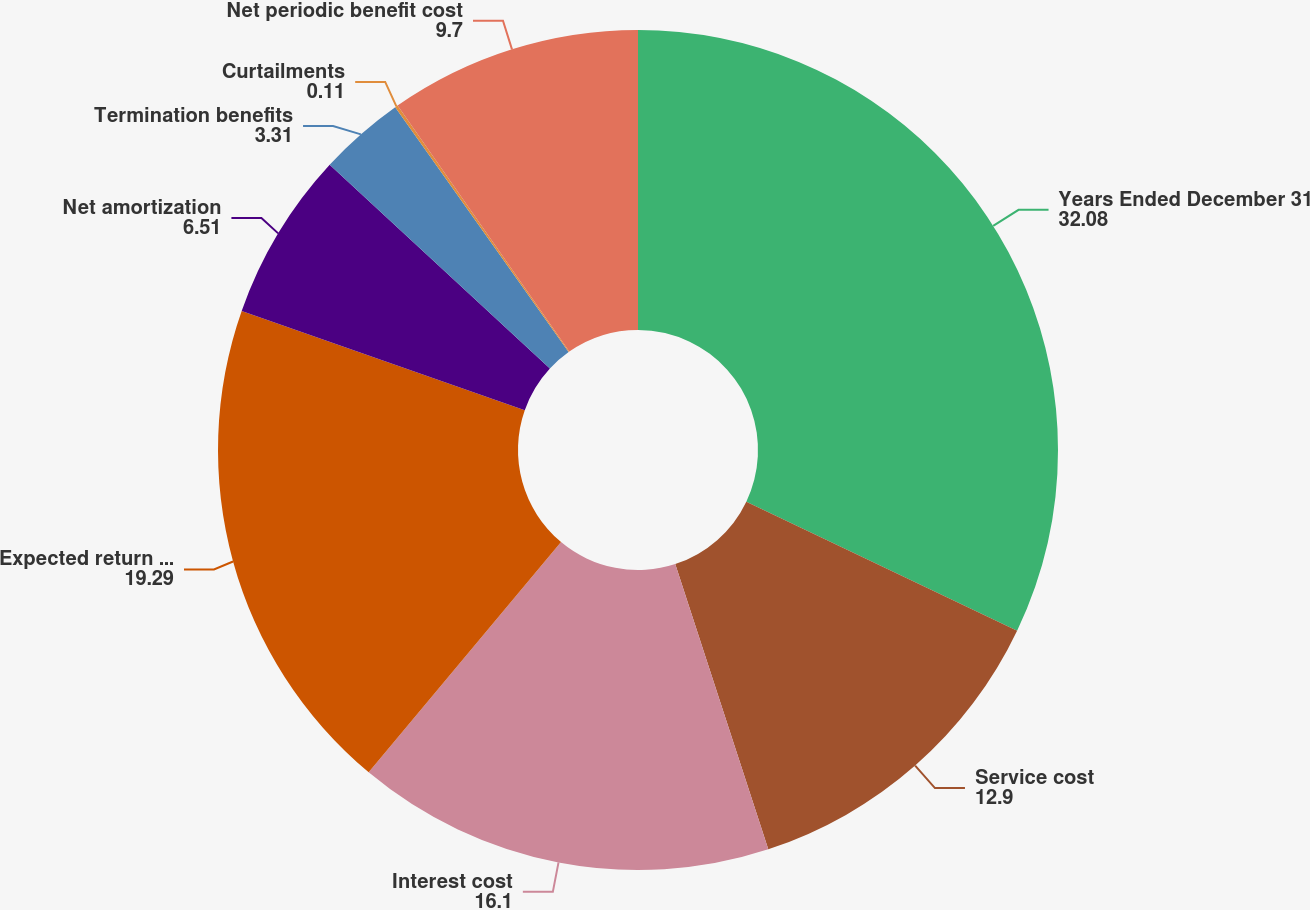Convert chart. <chart><loc_0><loc_0><loc_500><loc_500><pie_chart><fcel>Years Ended December 31<fcel>Service cost<fcel>Interest cost<fcel>Expected return on plan assets<fcel>Net amortization<fcel>Termination benefits<fcel>Curtailments<fcel>Net periodic benefit cost<nl><fcel>32.08%<fcel>12.9%<fcel>16.1%<fcel>19.29%<fcel>6.51%<fcel>3.31%<fcel>0.11%<fcel>9.7%<nl></chart> 